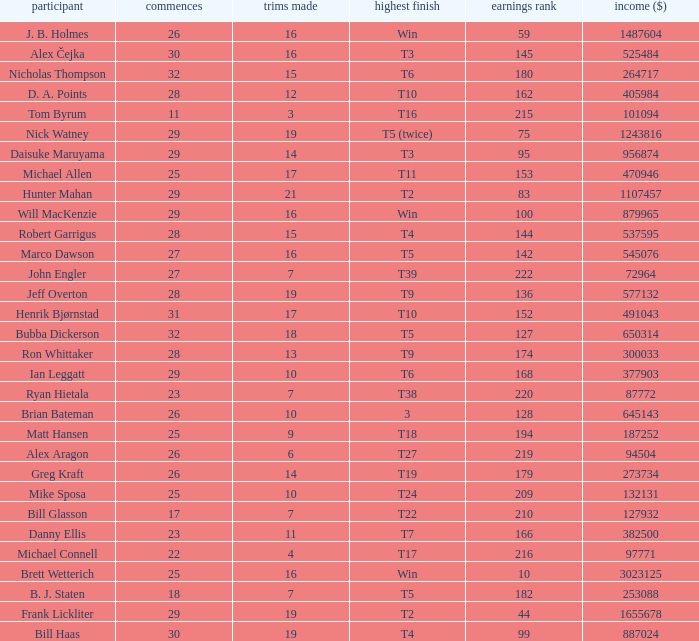What is the minimum number of starts for the players having a best finish of T18? 25.0. 